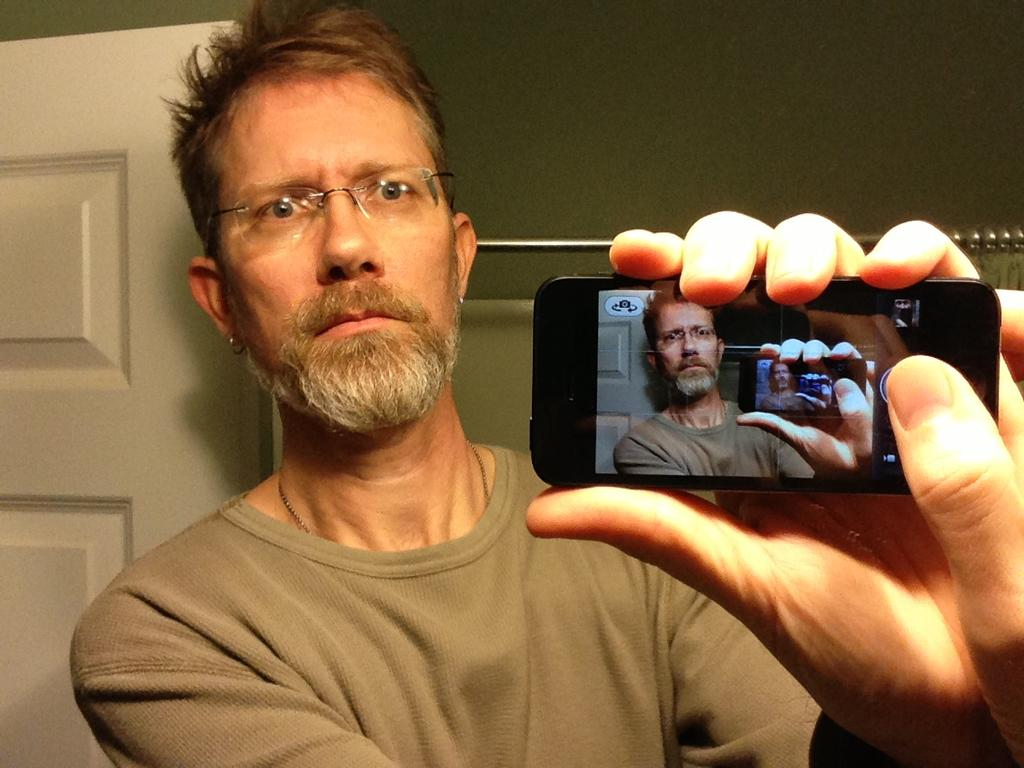What is the main subject of the image? There is a person in the image. What is the person holding in his hands? The person is holding a phone in his hands. What is the person doing with the phone? The person is clicking his picture. What color is the background wall in the image? The background wall is green in color. What type of cake can be seen on the person's plate in the image? There is no cake or plate present in the image; the person is holding a phone and clicking his picture. 